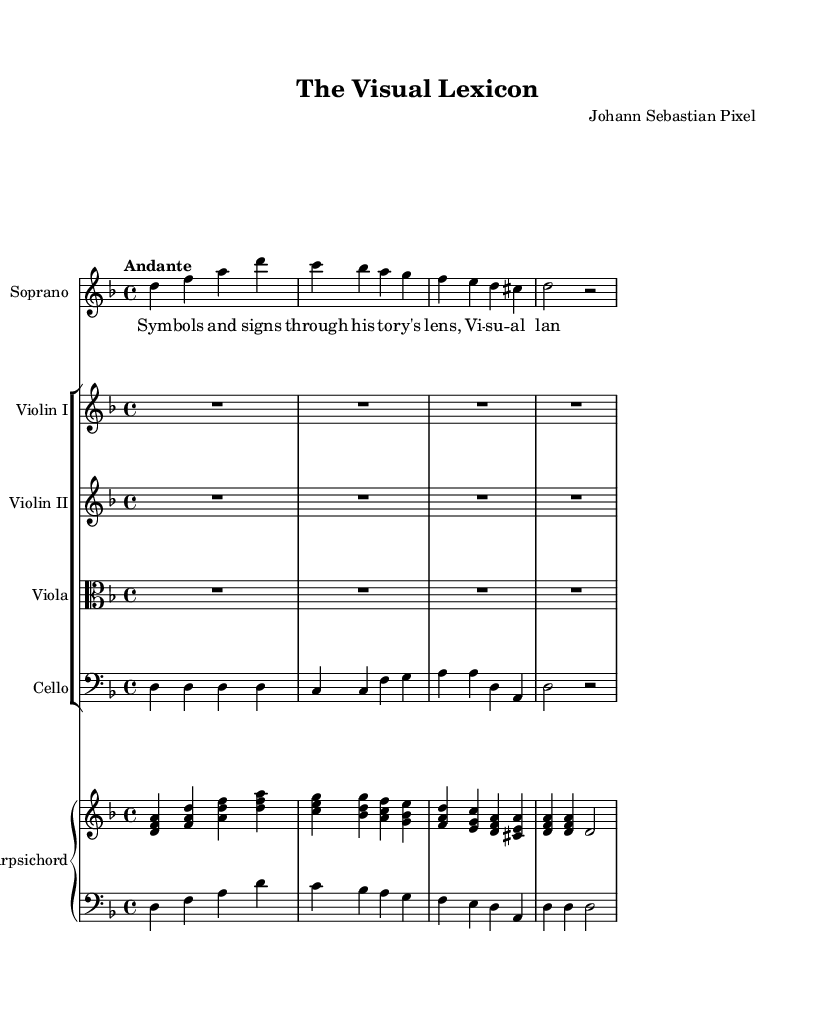What is the key signature of this music? The key signature is determined by the two sharps visible at the beginning of the staff, indicating D minor.
Answer: D minor What is the time signature of this music? The time signature is indicated at the beginning, showing a 4 over 4. This means there are four beats in each measure.
Answer: 4/4 What is the tempo marking of this piece? The tempo marking is indicated above the music in Italian, stating "Andante," which means a moderately slow tempo.
Answer: Andante How many instruments are featured in this composition? By counting the different staves, we find one soprano, two violins, a viola, a cello, and a harpsichord, totaling five distinct instruments.
Answer: Five What is the structured form of the composition? The structure is suggested by each part being labeled with different instrument names, indicating it follows a typical orchestral structure found in Baroque operas.
Answer: Orchestral structure Which voice part has lyrics associated with it? The lyrics are specifically attached to the soprano part, as indicated by the corresponding label and the presence of written words beneath the notes.
Answer: Soprano What is the musical texture of this piece? The texture can be inferred from the multiple instruments playing together, creating a rich interplay typical of Baroque music characterized by harmony and counterpoint.
Answer: Polyphonic 